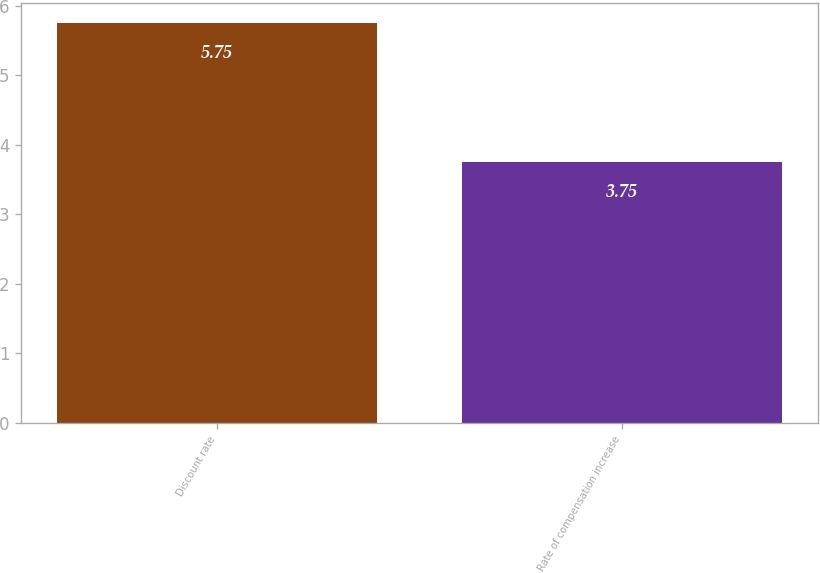Convert chart to OTSL. <chart><loc_0><loc_0><loc_500><loc_500><bar_chart><fcel>Discount rate<fcel>Rate of compensation increase<nl><fcel>5.75<fcel>3.75<nl></chart> 